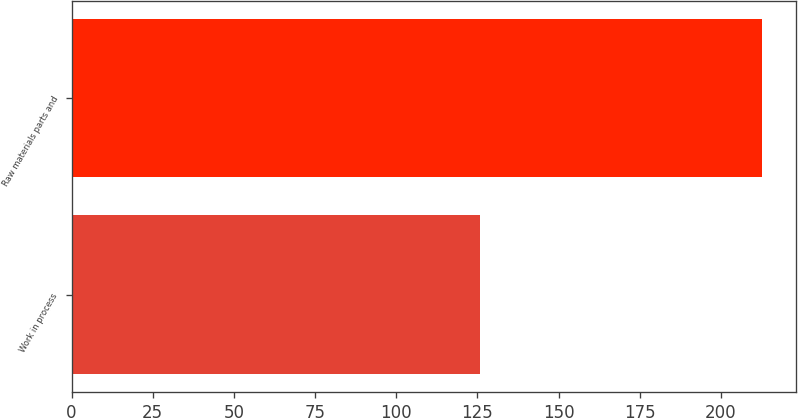<chart> <loc_0><loc_0><loc_500><loc_500><bar_chart><fcel>Work in process<fcel>Raw materials parts and<nl><fcel>125.9<fcel>212.6<nl></chart> 